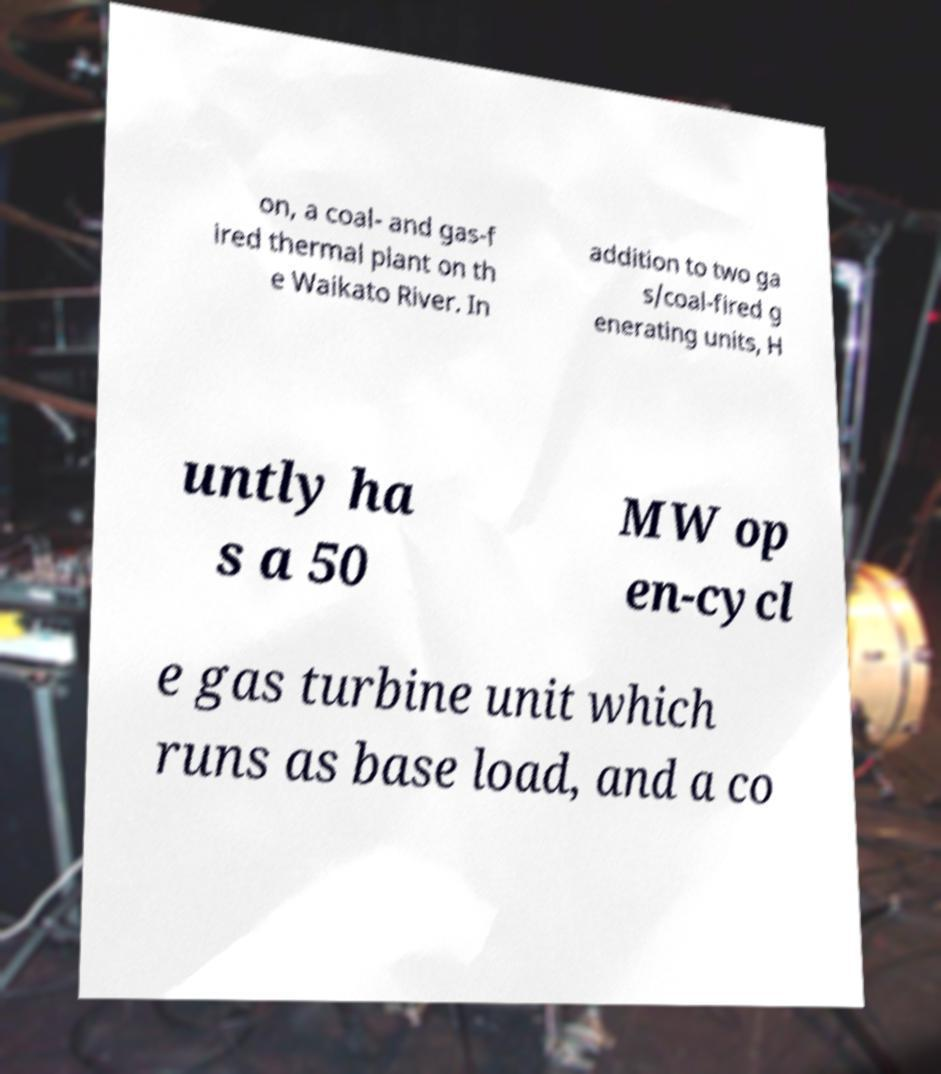There's text embedded in this image that I need extracted. Can you transcribe it verbatim? on, a coal- and gas-f ired thermal plant on th e Waikato River. In addition to two ga s/coal-fired g enerating units, H untly ha s a 50 MW op en-cycl e gas turbine unit which runs as base load, and a co 